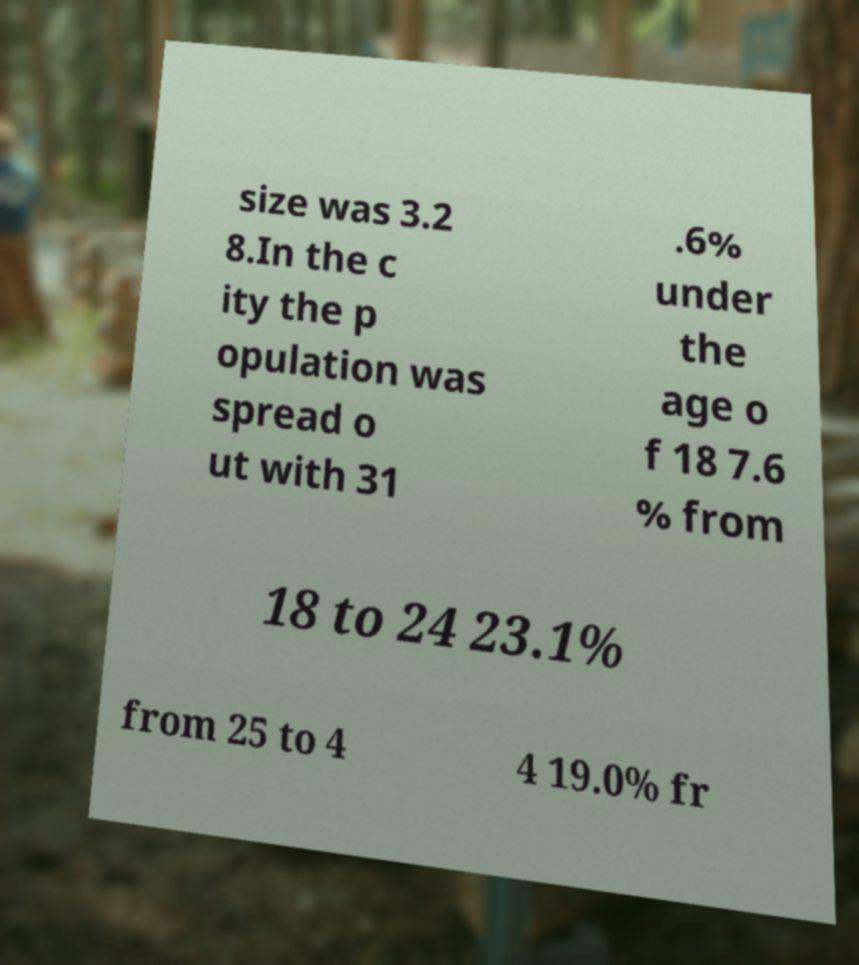Please identify and transcribe the text found in this image. size was 3.2 8.In the c ity the p opulation was spread o ut with 31 .6% under the age o f 18 7.6 % from 18 to 24 23.1% from 25 to 4 4 19.0% fr 